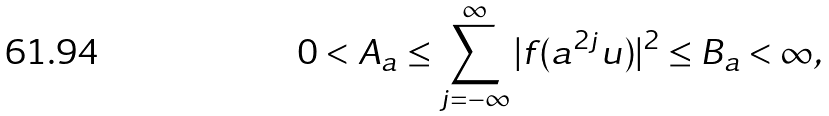Convert formula to latex. <formula><loc_0><loc_0><loc_500><loc_500>0 < A _ { a } \leq \sum _ { j = - \infty } ^ { \infty } | f ( a ^ { 2 j } u ) | ^ { 2 } \leq B _ { a } < \infty ,</formula> 